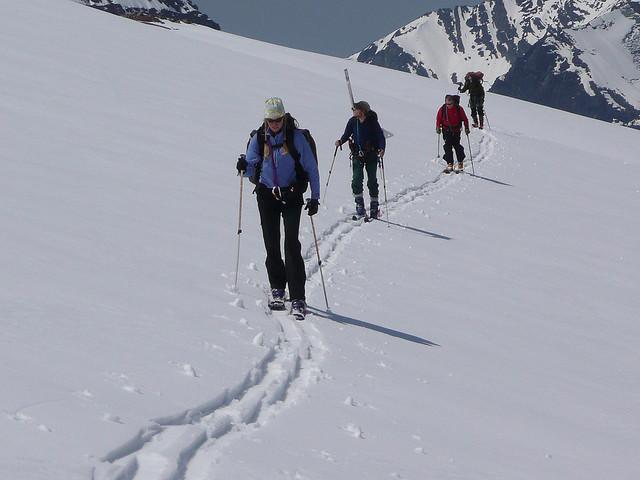Where is the skier with the blue parka?
Quick response, please. In front. Are these people walking in a straight line or side by side?
Answer briefly. Straight line. Is this person's whole body facing the camera?
Short answer required. Yes. What kind of skiers are they?
Be succinct. Cross country. 